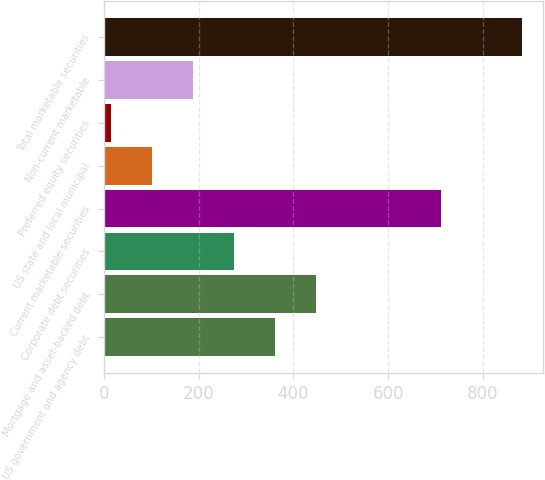Convert chart. <chart><loc_0><loc_0><loc_500><loc_500><bar_chart><fcel>US government and agency debt<fcel>Mortgage and asset-backed debt<fcel>Corporate debt securities<fcel>Current marketable securities<fcel>US state and local municipal<fcel>Preferred equity securities<fcel>Non-current marketable<fcel>Total marketable securities<nl><fcel>361.6<fcel>448.5<fcel>274.7<fcel>711<fcel>100.9<fcel>14<fcel>187.8<fcel>883<nl></chart> 